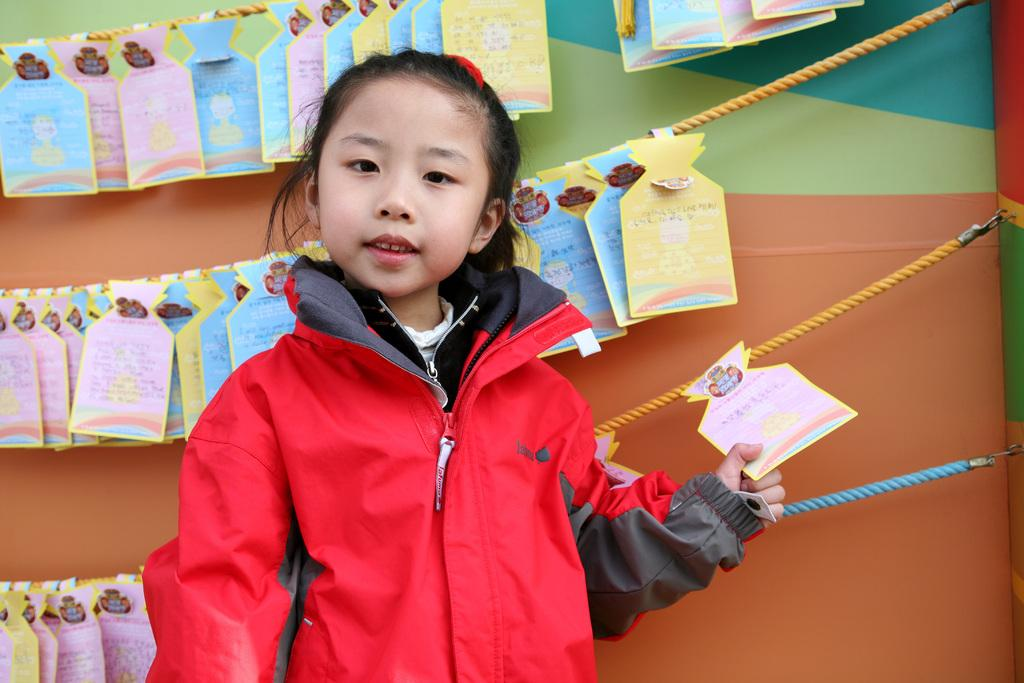Who is the main subject in the image? There is a girl in the image. What is the girl holding in her hand? The girl is holding a paper in her hand. What other objects can be seen in the image? There are ropes and paper boards visible in the image. What type of structure is present in the image? There is a wall in the image. Where might this image have been taken? The image may have been taken in a hall, based on the presence of paper boards and the wall. What is the title of the book the servant is holding in the image? There is no servant or book present in the image; it features a girl holding a paper. 